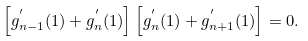Convert formula to latex. <formula><loc_0><loc_0><loc_500><loc_500>\left [ g ^ { ^ { \prime } } _ { n - 1 } ( 1 ) + g ^ { ^ { \prime } } _ { n } ( 1 ) \right ] \left [ g ^ { ^ { \prime } } _ { n } ( 1 ) + g ^ { ^ { \prime } } _ { n + 1 } ( 1 ) \right ] = 0 .</formula> 